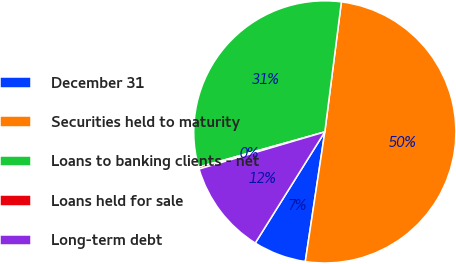Convert chart. <chart><loc_0><loc_0><loc_500><loc_500><pie_chart><fcel>December 31<fcel>Securities held to maturity<fcel>Loans to banking clients - net<fcel>Loans held for sale<fcel>Long-term debt<nl><fcel>6.52%<fcel>50.37%<fcel>31.35%<fcel>0.24%<fcel>11.53%<nl></chart> 